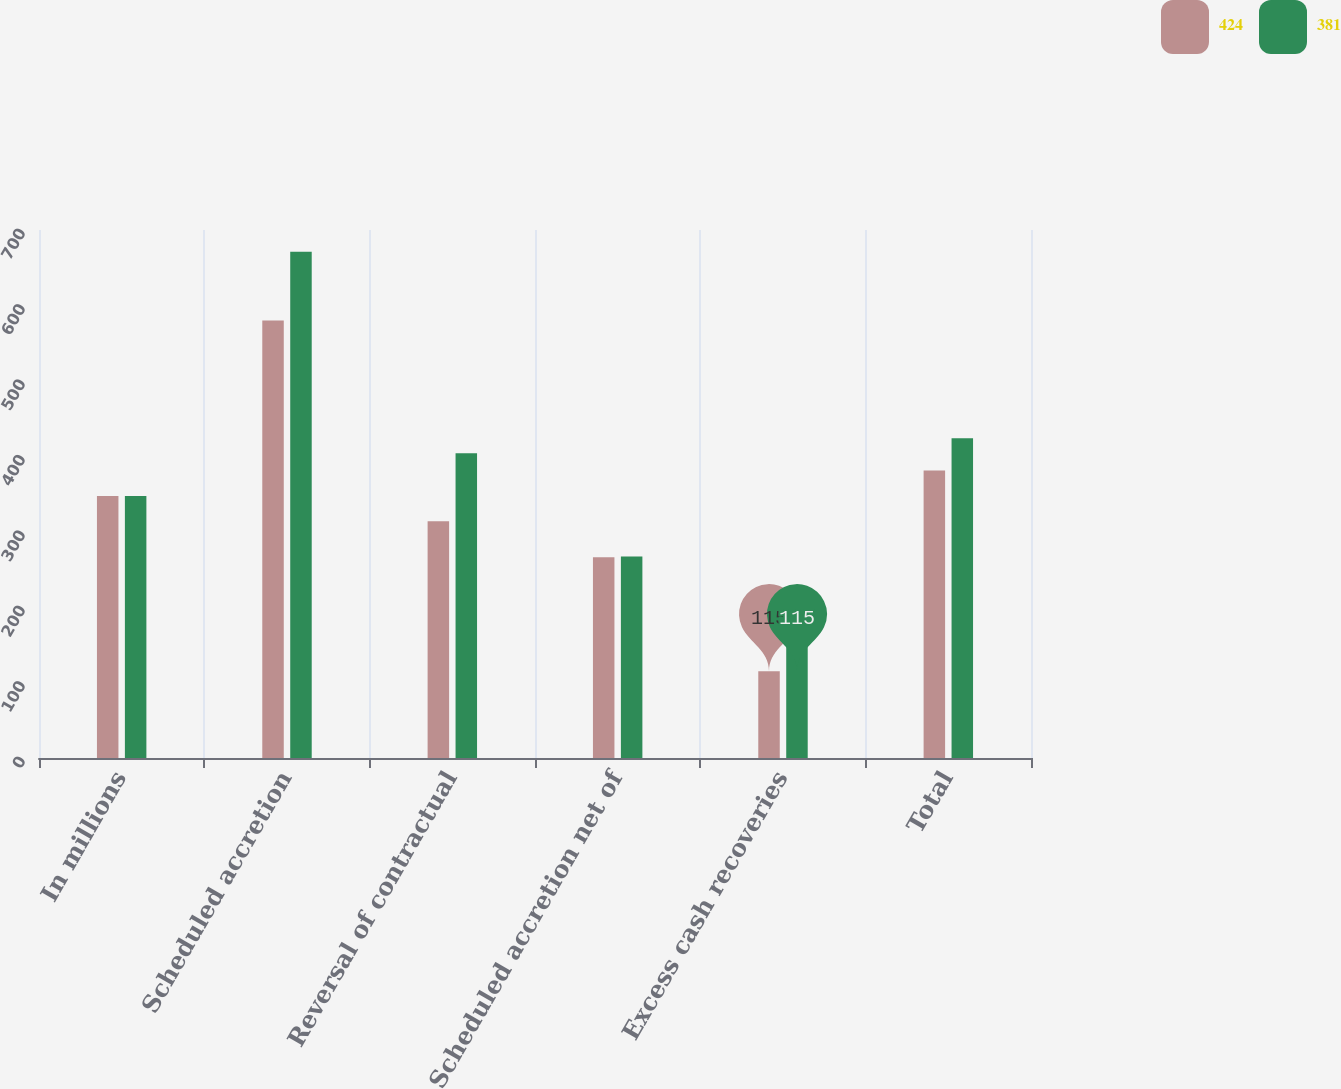Convert chart. <chart><loc_0><loc_0><loc_500><loc_500><stacked_bar_chart><ecel><fcel>In millions<fcel>Scheduled accretion<fcel>Reversal of contractual<fcel>Scheduled accretion net of<fcel>Excess cash recoveries<fcel>Total<nl><fcel>424<fcel>347.5<fcel>580<fcel>314<fcel>266<fcel>115<fcel>381<nl><fcel>381<fcel>347.5<fcel>671<fcel>404<fcel>267<fcel>157<fcel>424<nl></chart> 